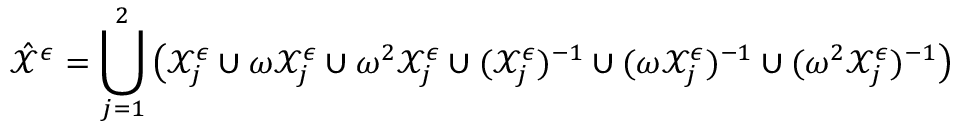<formula> <loc_0><loc_0><loc_500><loc_500>\hat { \mathcal { X } } ^ { \epsilon } = \bigcup _ { j = 1 } ^ { 2 } \left ( \mathcal { X } _ { j } ^ { \epsilon } \cup \omega \mathcal { X } _ { j } ^ { \epsilon } \cup \omega ^ { 2 } \mathcal { X } _ { j } ^ { \epsilon } \cup ( \mathcal { X } _ { j } ^ { \epsilon } ) ^ { - 1 } \cup ( \omega \mathcal { X } _ { j } ^ { \epsilon } ) ^ { - 1 } \cup ( \omega ^ { 2 } \mathcal { X } _ { j } ^ { \epsilon } ) ^ { - 1 } \right )</formula> 